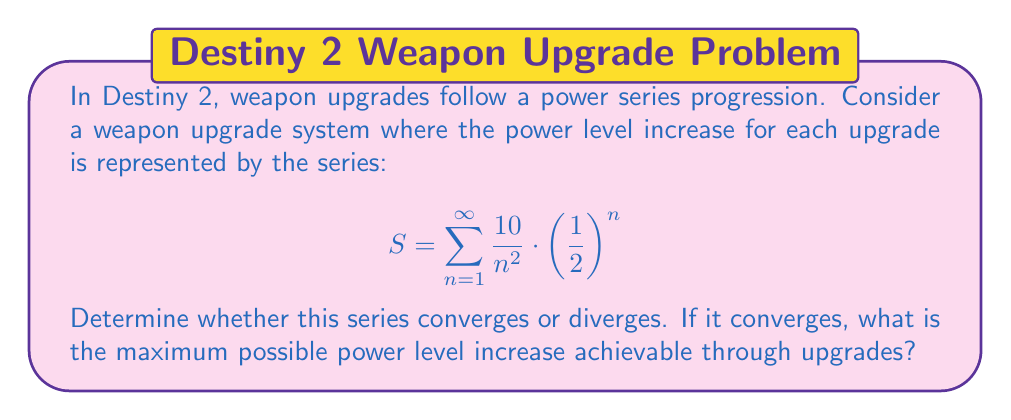Could you help me with this problem? To analyze the convergence of this power series, we can use the ratio test:

1) First, let's define the general term of the series:
   $$a_n = \frac{10}{n^2} \cdot \left(\frac{1}{2}\right)^n$$

2) Now, we calculate the limit of the ratio of consecutive terms:
   $$\lim_{n \to \infty} \left|\frac{a_{n+1}}{a_n}\right| = \lim_{n \to \infty} \left|\frac{\frac{10}{(n+1)^2} \cdot \left(\frac{1}{2}\right)^{n+1}}{\frac{10}{n^2} \cdot \left(\frac{1}{2}\right)^n}\right|$$

3) Simplify:
   $$\lim_{n \to \infty} \left|\frac{n^2}{(n+1)^2} \cdot \frac{1}{2}\right|$$

4) As $n$ approaches infinity, $\frac{n^2}{(n+1)^2}$ approaches 1:
   $$\lim_{n \to \infty} \left|\frac{1}{2}\right| = \frac{1}{2}$$

5) Since the limit is less than 1, the series converges by the ratio test.

6) To find the sum of the series, we can use the fact that it converges and compare it to a known series:
   $$\sum_{n=1}^{\infty} \frac{1}{n^2} = \frac{\pi^2}{6}$$ (Basel problem)

7) Our series can be rewritten as:
   $$S = 10 \cdot \sum_{n=1}^{\infty} \frac{1}{n^2} \cdot \left(\frac{1}{2}\right)^n$$

8) This is less than:
   $$10 \cdot \sum_{n=1}^{\infty} \frac{1}{n^2} = 10 \cdot \frac{\pi^2}{6} \approx 16.45$$

Therefore, the maximum possible power level increase is less than 16.45.
Answer: The series converges. The maximum possible power level increase is less than 16.45. 